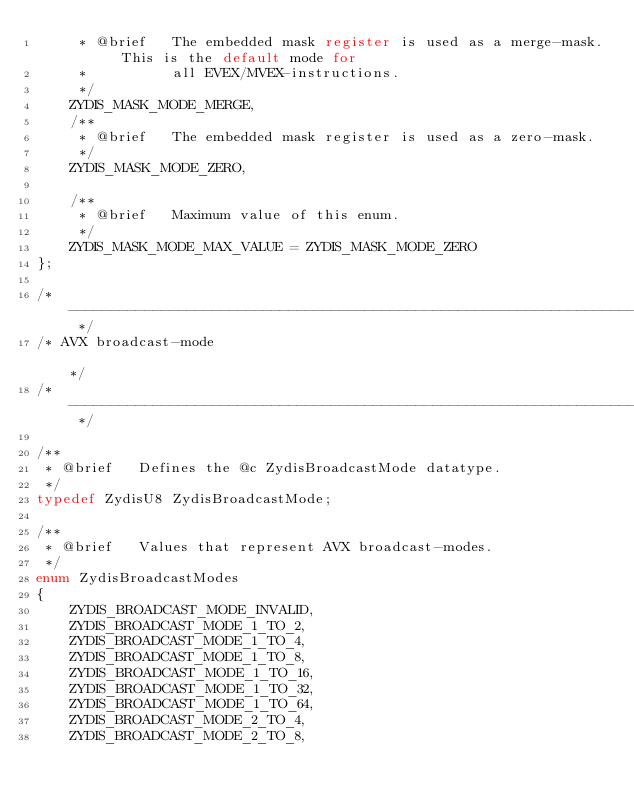Convert code to text. <code><loc_0><loc_0><loc_500><loc_500><_C_>     * @brief   The embedded mask register is used as a merge-mask. This is the default mode for
     *          all EVEX/MVEX-instructions.
     */
    ZYDIS_MASK_MODE_MERGE,
    /**
     * @brief   The embedded mask register is used as a zero-mask.
     */
    ZYDIS_MASK_MODE_ZERO,

    /**
     * @brief   Maximum value of this enum.
     */
    ZYDIS_MASK_MODE_MAX_VALUE = ZYDIS_MASK_MODE_ZERO
};

/* ---------------------------------------------------------------------------------------------- */
/* AVX broadcast-mode                                                                             */
/* ---------------------------------------------------------------------------------------------- */

/**
 * @brief   Defines the @c ZydisBroadcastMode datatype.
 */
typedef ZydisU8 ZydisBroadcastMode;

/**
 * @brief   Values that represent AVX broadcast-modes.
 */
enum ZydisBroadcastModes
{
    ZYDIS_BROADCAST_MODE_INVALID,
    ZYDIS_BROADCAST_MODE_1_TO_2,
    ZYDIS_BROADCAST_MODE_1_TO_4,
    ZYDIS_BROADCAST_MODE_1_TO_8,
    ZYDIS_BROADCAST_MODE_1_TO_16,
    ZYDIS_BROADCAST_MODE_1_TO_32,
    ZYDIS_BROADCAST_MODE_1_TO_64,
    ZYDIS_BROADCAST_MODE_2_TO_4,
    ZYDIS_BROADCAST_MODE_2_TO_8,</code> 